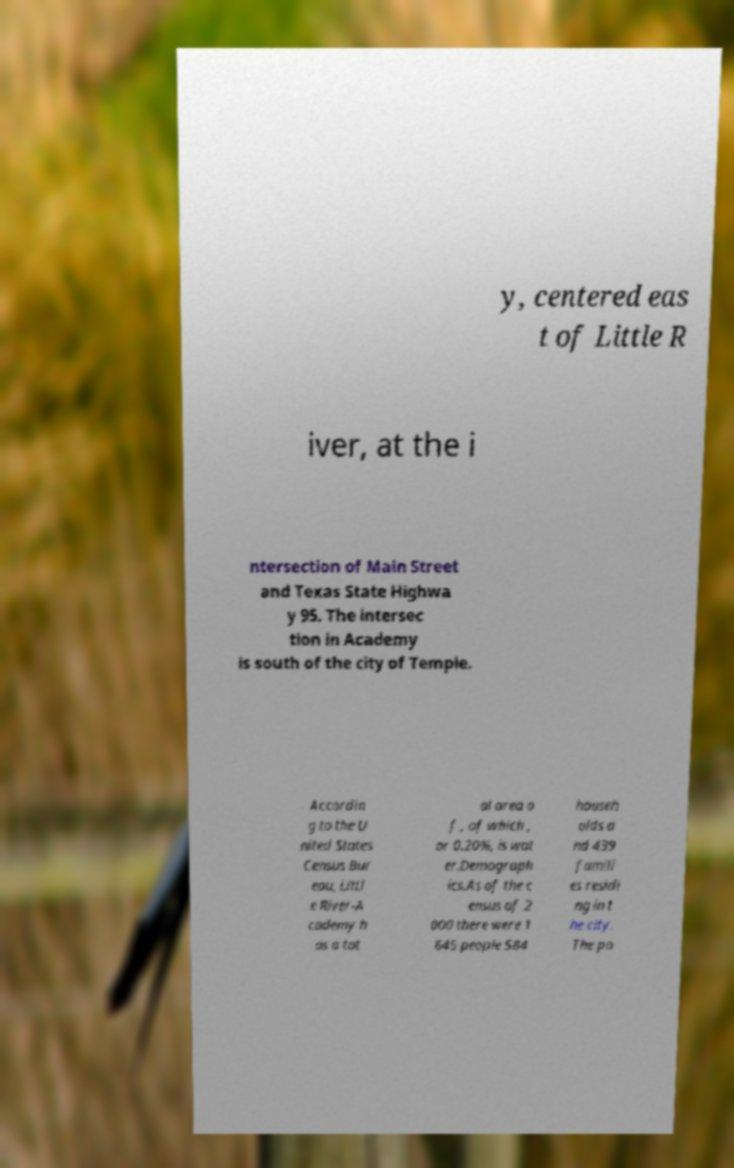Can you read and provide the text displayed in the image?This photo seems to have some interesting text. Can you extract and type it out for me? y, centered eas t of Little R iver, at the i ntersection of Main Street and Texas State Highwa y 95. The intersec tion in Academy is south of the city of Temple. Accordin g to the U nited States Census Bur eau, Littl e River-A cademy h as a tot al area o f , of which , or 0.20%, is wat er.Demograph ics.As of the c ensus of 2 000 there were 1 645 people 584 househ olds a nd 439 famili es residi ng in t he city. The po 